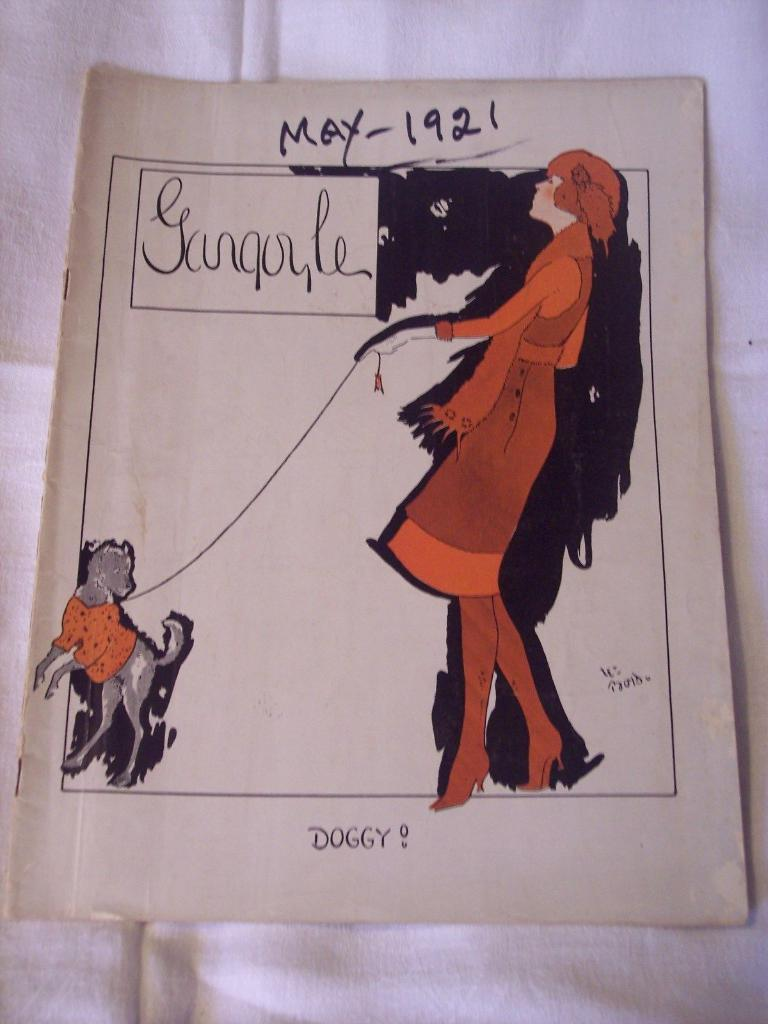What is present on the wall in the image? There is a poster in the image. What can be found on the poster? The poster contains images and text. What color is the surface behind the poster? The surface behind the poster is white-colored. How many fans are visible in the image? There are no fans present in the image. What type of hand is shown holding the poster in the image? There is no hand present in the image. The poster is attached to the wall. 